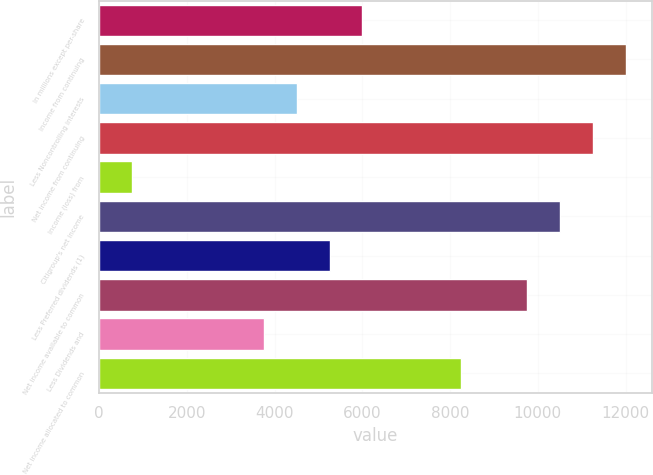<chart> <loc_0><loc_0><loc_500><loc_500><bar_chart><fcel>In millions except per-share<fcel>Income from continuing<fcel>Less Noncontrolling interests<fcel>Net income from continuing<fcel>Income (loss) from<fcel>Citigroup's net income<fcel>Less Preferred dividends (1)<fcel>Net income available to common<fcel>Less Dividends and<fcel>Net income allocated to common<nl><fcel>6003.26<fcel>12006.2<fcel>4502.52<fcel>11255.9<fcel>750.67<fcel>10505.5<fcel>5252.89<fcel>9755.11<fcel>3752.15<fcel>8254.37<nl></chart> 